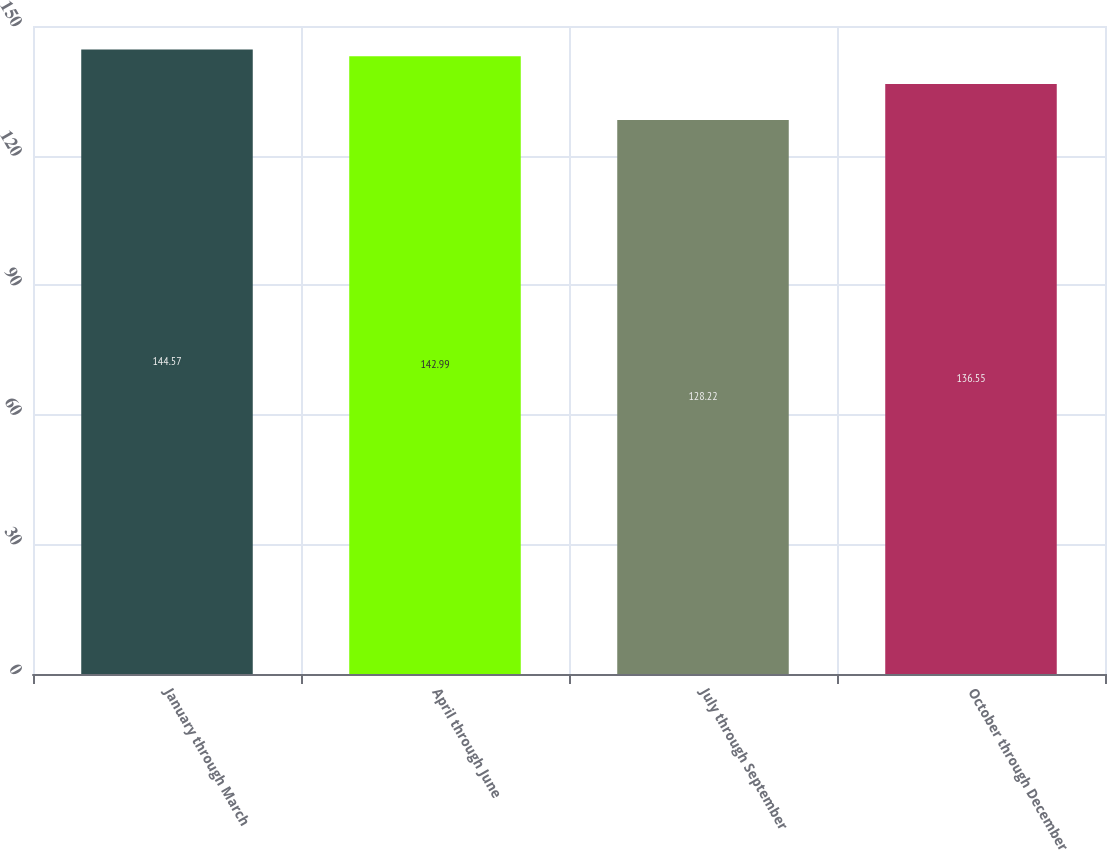Convert chart to OTSL. <chart><loc_0><loc_0><loc_500><loc_500><bar_chart><fcel>January through March<fcel>April through June<fcel>July through September<fcel>October through December<nl><fcel>144.57<fcel>142.99<fcel>128.22<fcel>136.55<nl></chart> 